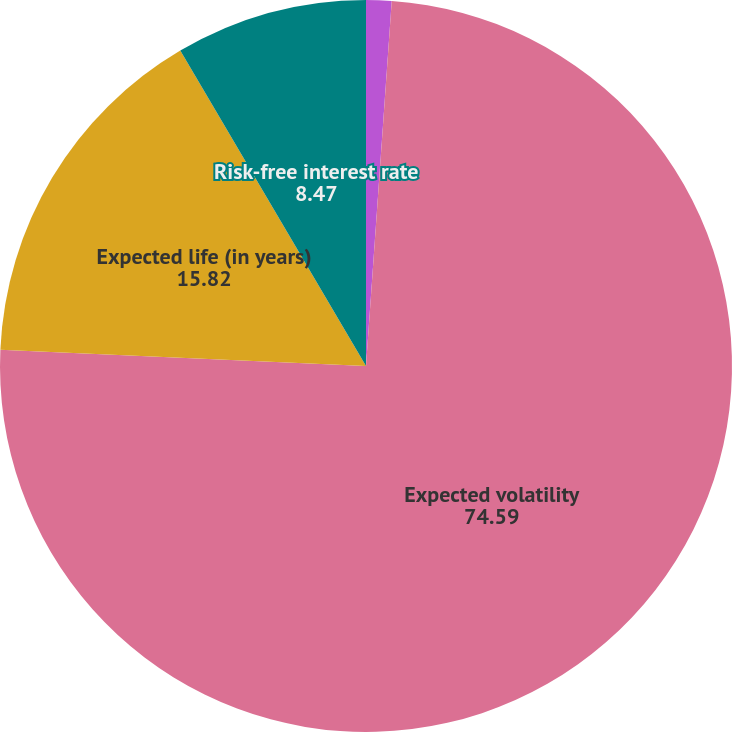Convert chart. <chart><loc_0><loc_0><loc_500><loc_500><pie_chart><fcel>Expected dividend yield<fcel>Expected volatility<fcel>Expected life (in years)<fcel>Risk-free interest rate<nl><fcel>1.12%<fcel>74.59%<fcel>15.82%<fcel>8.47%<nl></chart> 